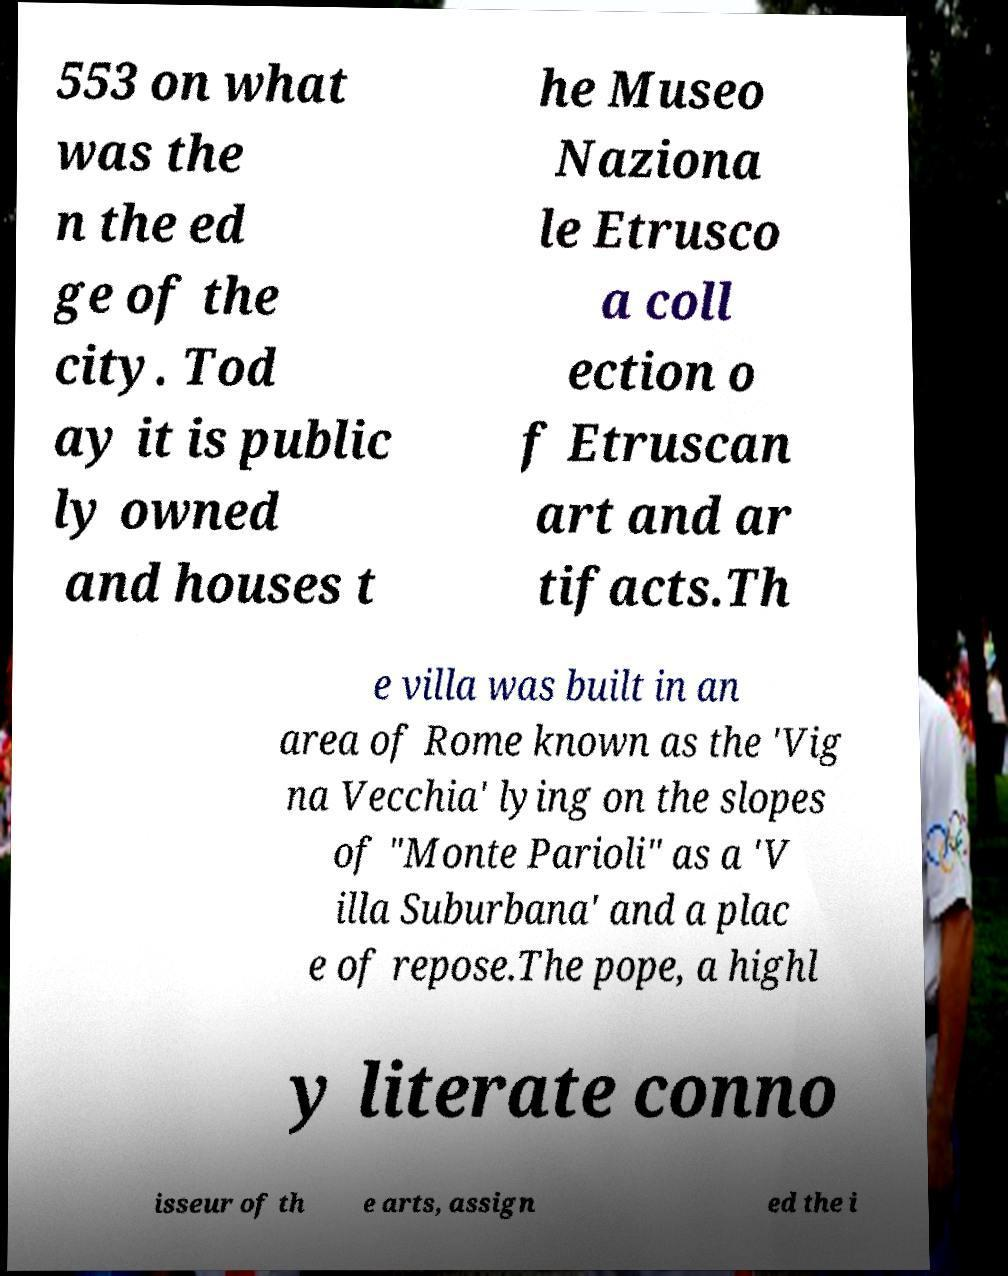What messages or text are displayed in this image? I need them in a readable, typed format. 553 on what was the n the ed ge of the city. Tod ay it is public ly owned and houses t he Museo Naziona le Etrusco a coll ection o f Etruscan art and ar tifacts.Th e villa was built in an area of Rome known as the 'Vig na Vecchia' lying on the slopes of "Monte Parioli" as a 'V illa Suburbana' and a plac e of repose.The pope, a highl y literate conno isseur of th e arts, assign ed the i 